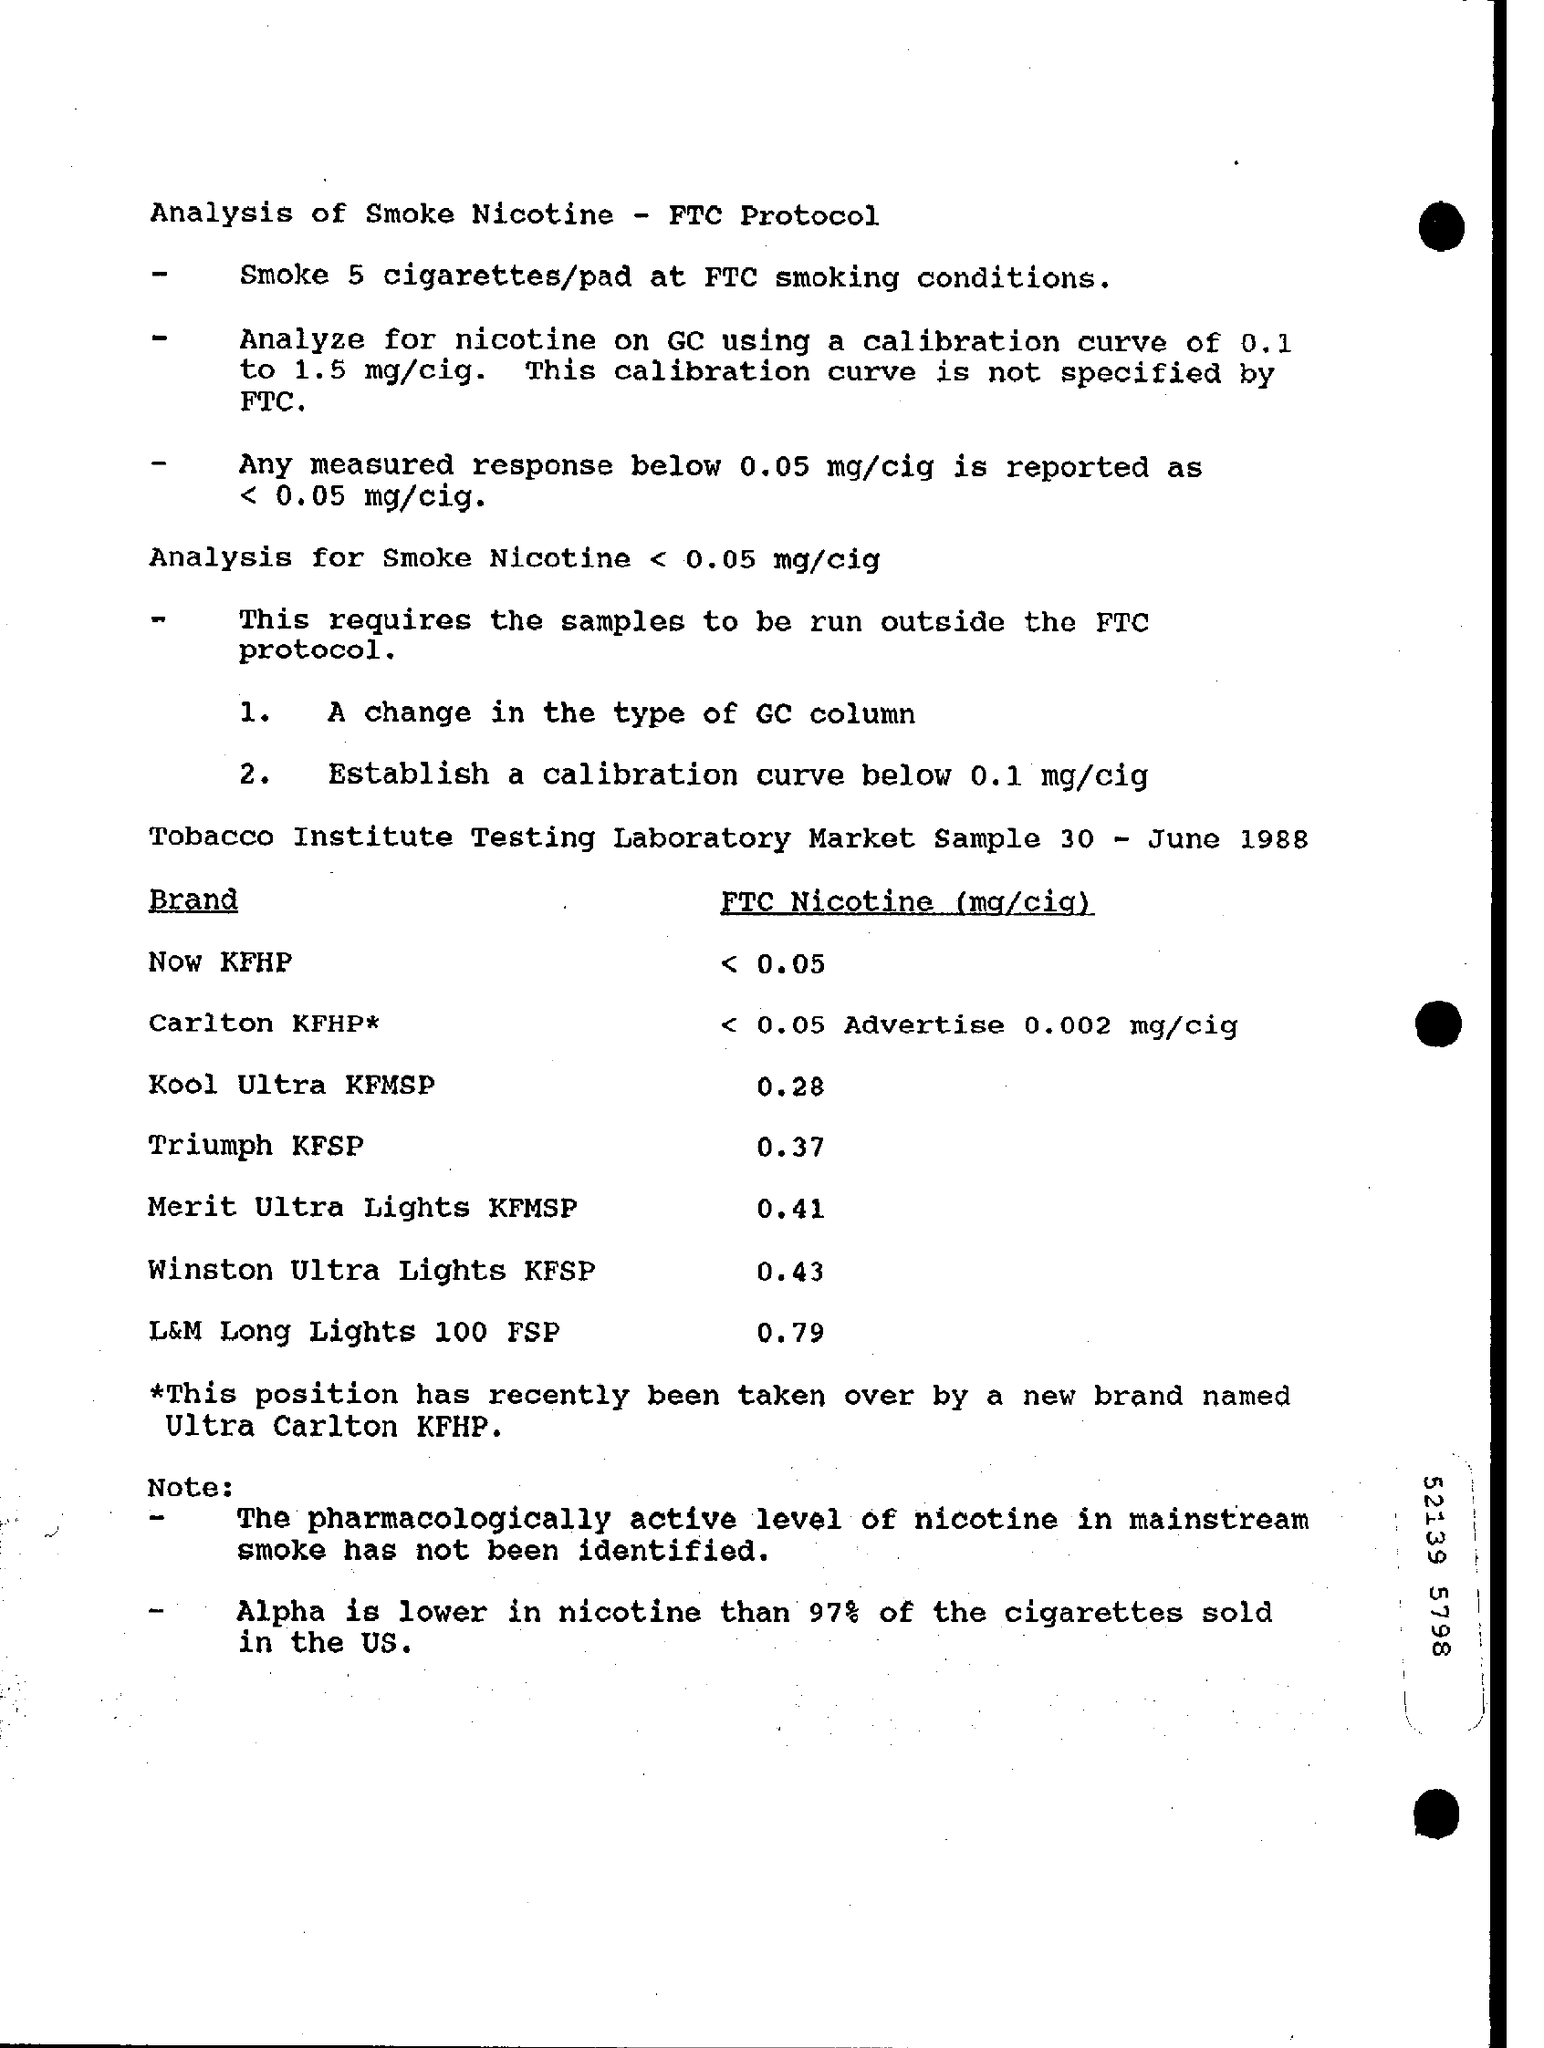Indicate a few pertinent items in this graphic. The FTC Nicotin level for the brand "Triumph KFSP" is 0.37 milligrams per cigarette, according to the provided information. The analysis of nicotine using gas chromatography with a calibration curve ranging from 0.1 to 1.5 milligrams per cigarette has been conducted. The FTC (Food and Drug Administration) measures nicotine levels in a unit of milligrams per cigarette (mg/cig). The FTC Nicotin level for the brand "Winston Ultra Lights KFSP" is 0.43 milligrams per cigarette. The FTC Nicotin level for the brand 'Kool Ultra KFMSP' is 0.28 mg/cig. 